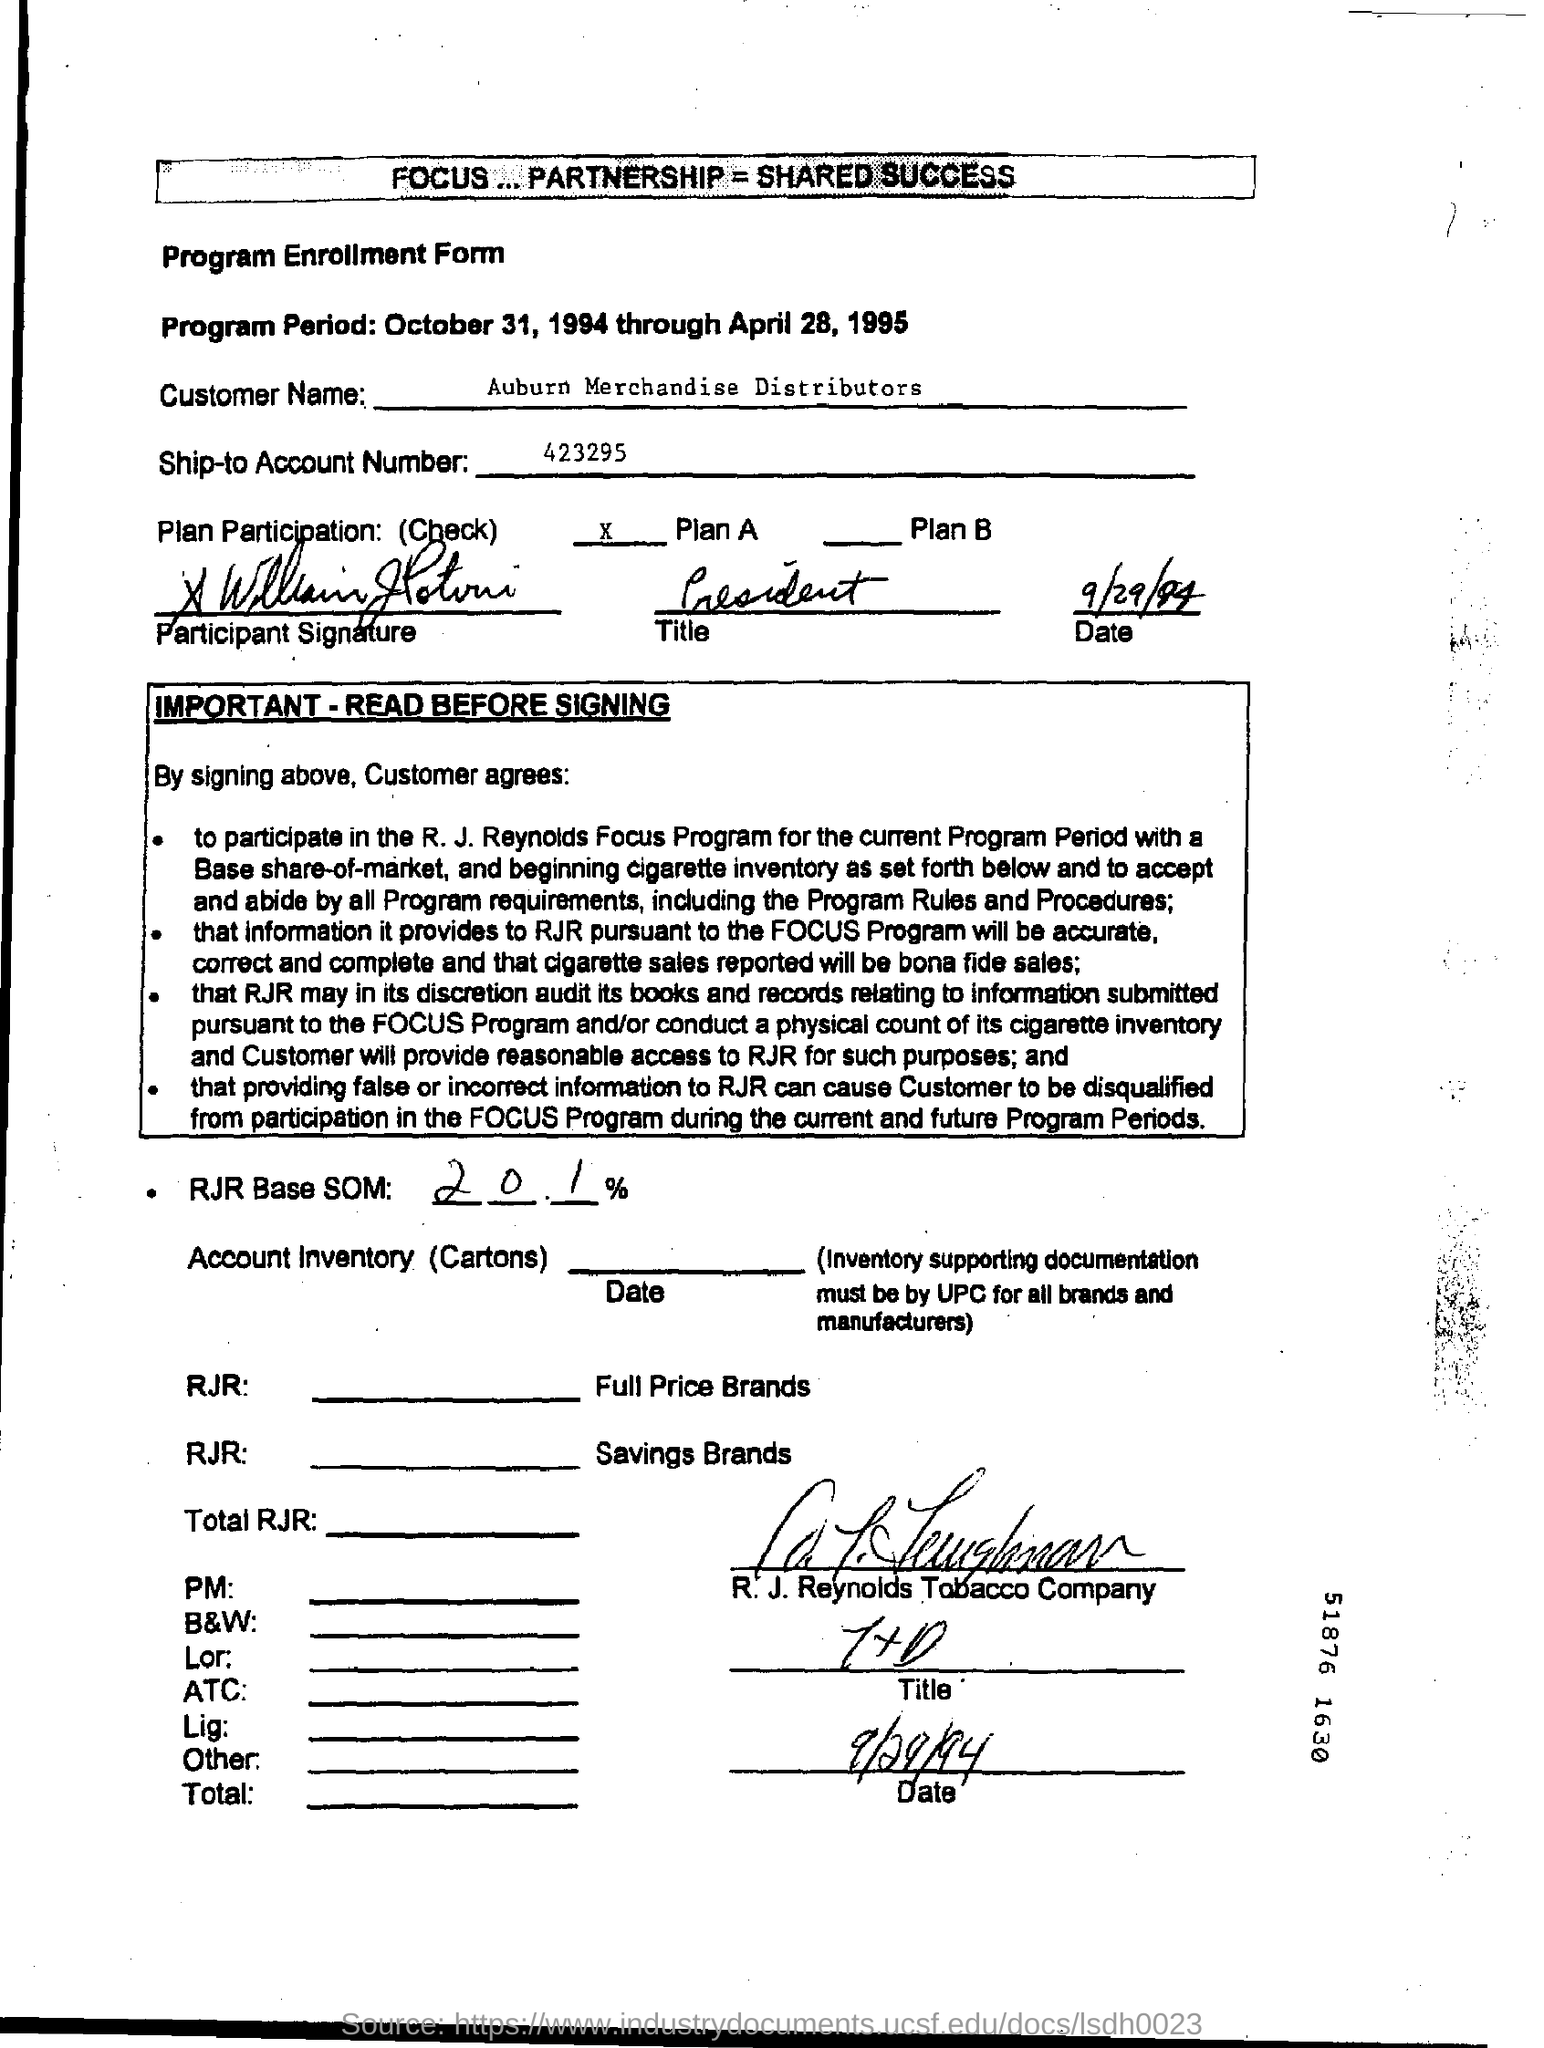What is the ship-to account no given in the form?
Make the answer very short. 423295. What is the Customer Name?
Give a very brief answer. Auburn Merchandise Distributors. What is the Ship-to Account Number ?
Your response must be concise. 423295. Which Date showing the Program Period ?
Ensure brevity in your answer.  October 31, 1994 through April 28, 1995. What is the Company Name ?
Ensure brevity in your answer.  R. J. Reynolds Tobacco Company. What is the Percentage of RJR Base SOM ?
Give a very brief answer. 20.1. What is the date mentioned in the bottom of the document ?
Provide a short and direct response. 9/29/94. 